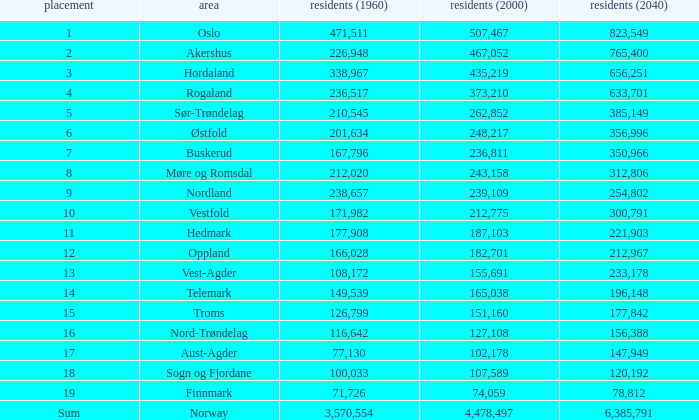What was the population of a county in 1960 that had a population of 467,052 in 2000 and 78,812 in 2040? None. 